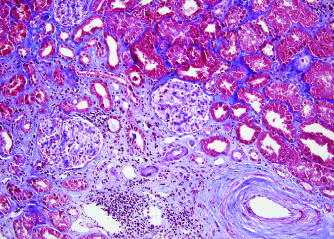what is shown (bottom right)?
Answer the question using a single word or phrase. An artery showing prominent arteriosclerosis 